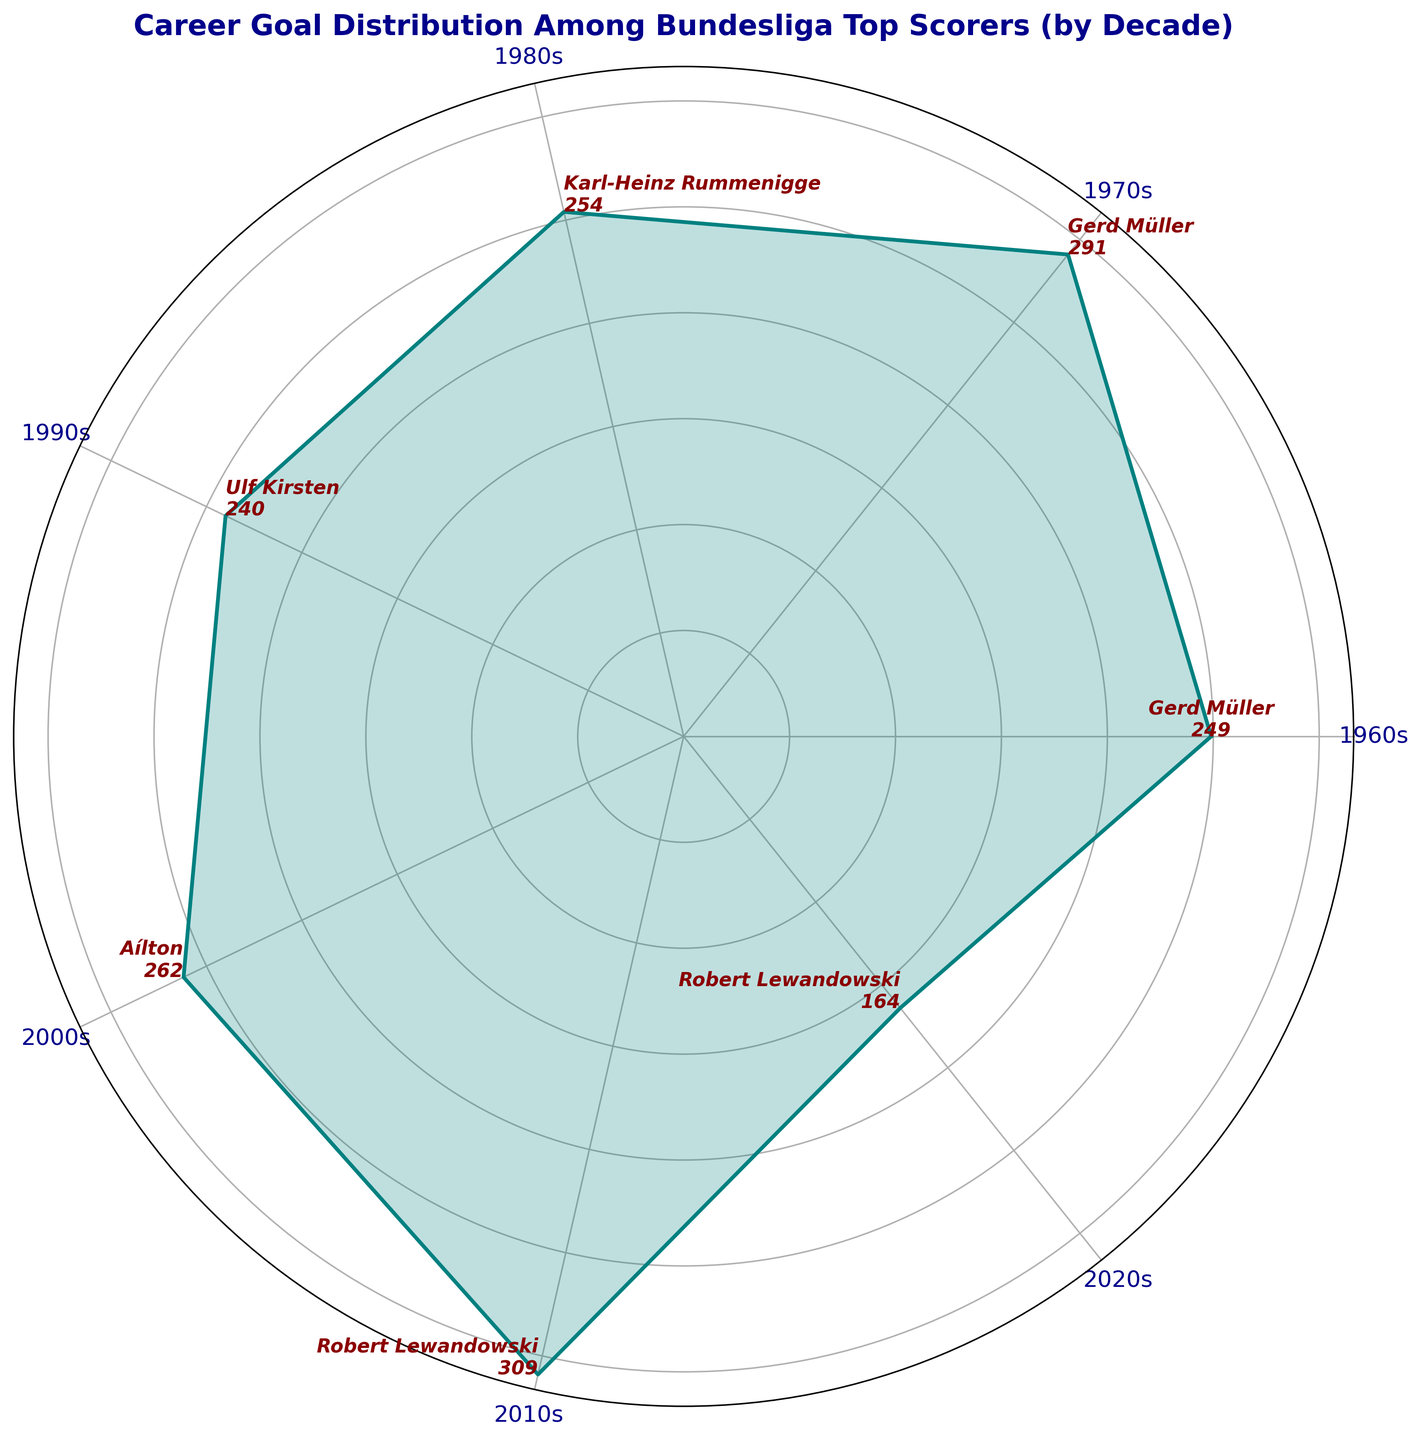What's the total number of goals scored in the 1960s and 1970s combined? First, find the number of goals scored in the 1960s (106 + 78 + 65 = 249). Next, find the number of goals scored in the 1970s (98 + 97 + 96 = 291). Finally, add the totals from both decades: 249 + 291 = 540.
Answer: 540 Which decade saw the highest number of career goals among top scorers? Looking at the plot, the decade with the highest value on the radial axis indicates the highest number of goals. The 2010s have the highest value.
Answer: 2010s How do the number of goals in the 1980s compare to those in the 2000s? First, find the total goals in the 1980s (85 + 83 + 86 = 254). Then find the total goals in the 2000s (80 + 87 + 95 = 262). Compare the totals: 254 vs. 262.
Answer: The 2000s have more goals Who is the top scorer in the 2010s and how many goals did they score? The annotation for each decade's top scorer shows the player's name and total goals. For the 2010s, Robert Lewandowski scored 110 goals.
Answer: Robert Lewandowski with 110 goals Which decades have a top scorer with over 100 goals? Check each decade for top scorers with over 100 goals. The 1960s (Gerd Müller, 106 goals), 2010s (Robert Lewandowski, 110 goals), and 2020s (Robert Lewandowski, 92 goals) meet this criteria.
Answer: 1960s and 2010s What's the difference in goals between the highest scorer in the 1970s and the highest scorer in the 2020s? Identify the highest scorer in each decade from the annotations: 1970s (Dieter Müller, 97 goals) and 2020s (Robert Lewandowski, 92 goals). Calculate the difference: 97 - 92 = 5 goals.
Answer: 5 goals During which decade did the distribution of goals appear to be the most even among top scorers? An even distribution in the rose chart will show similar lengths of the spokes for that decade. The 1970s have three players with very close goals (98, 97, 96).
Answer: 1970s How many goals did the top scorer in the 1990s achieve compared to the top scorer in the 1980s? Locate the top scorers for each of these decades from the annotations: 1990s (Ulf Kirsten, 90 goals) and 1980s (Karl-Heinz Rummenigge, 86 goals). Subtract: 90 - 86 = 4 goals.
Answer: 4 goals more in the 1990s What's the total number of goals scored by Gerd Müller across his career in the 1960s and 1970s? Sum Gerd Müller's goals in the 1960s (106) and 1970s (98). So, 106 + 98 = 204 goals.
Answer: 204 goals 